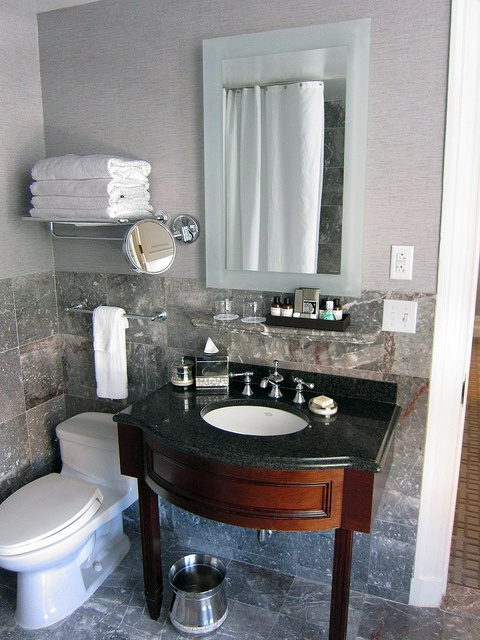Describe the objects in this image and their specific colors. I can see toilet in darkgray, lavender, and gray tones and sink in darkgray, lightgray, and black tones in this image. 